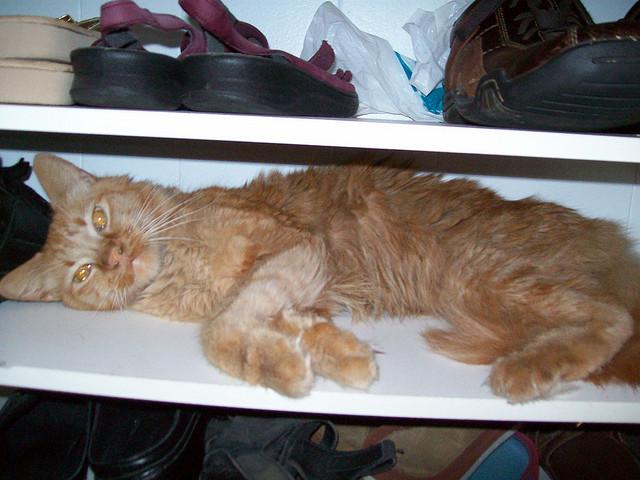Do these cats like shoes?
Be succinct. No. Is this cat healthy?
Write a very short answer. No. Where is the cat?
Quick response, please. Shelf. What color is the cat?
Short answer required. Orange. 